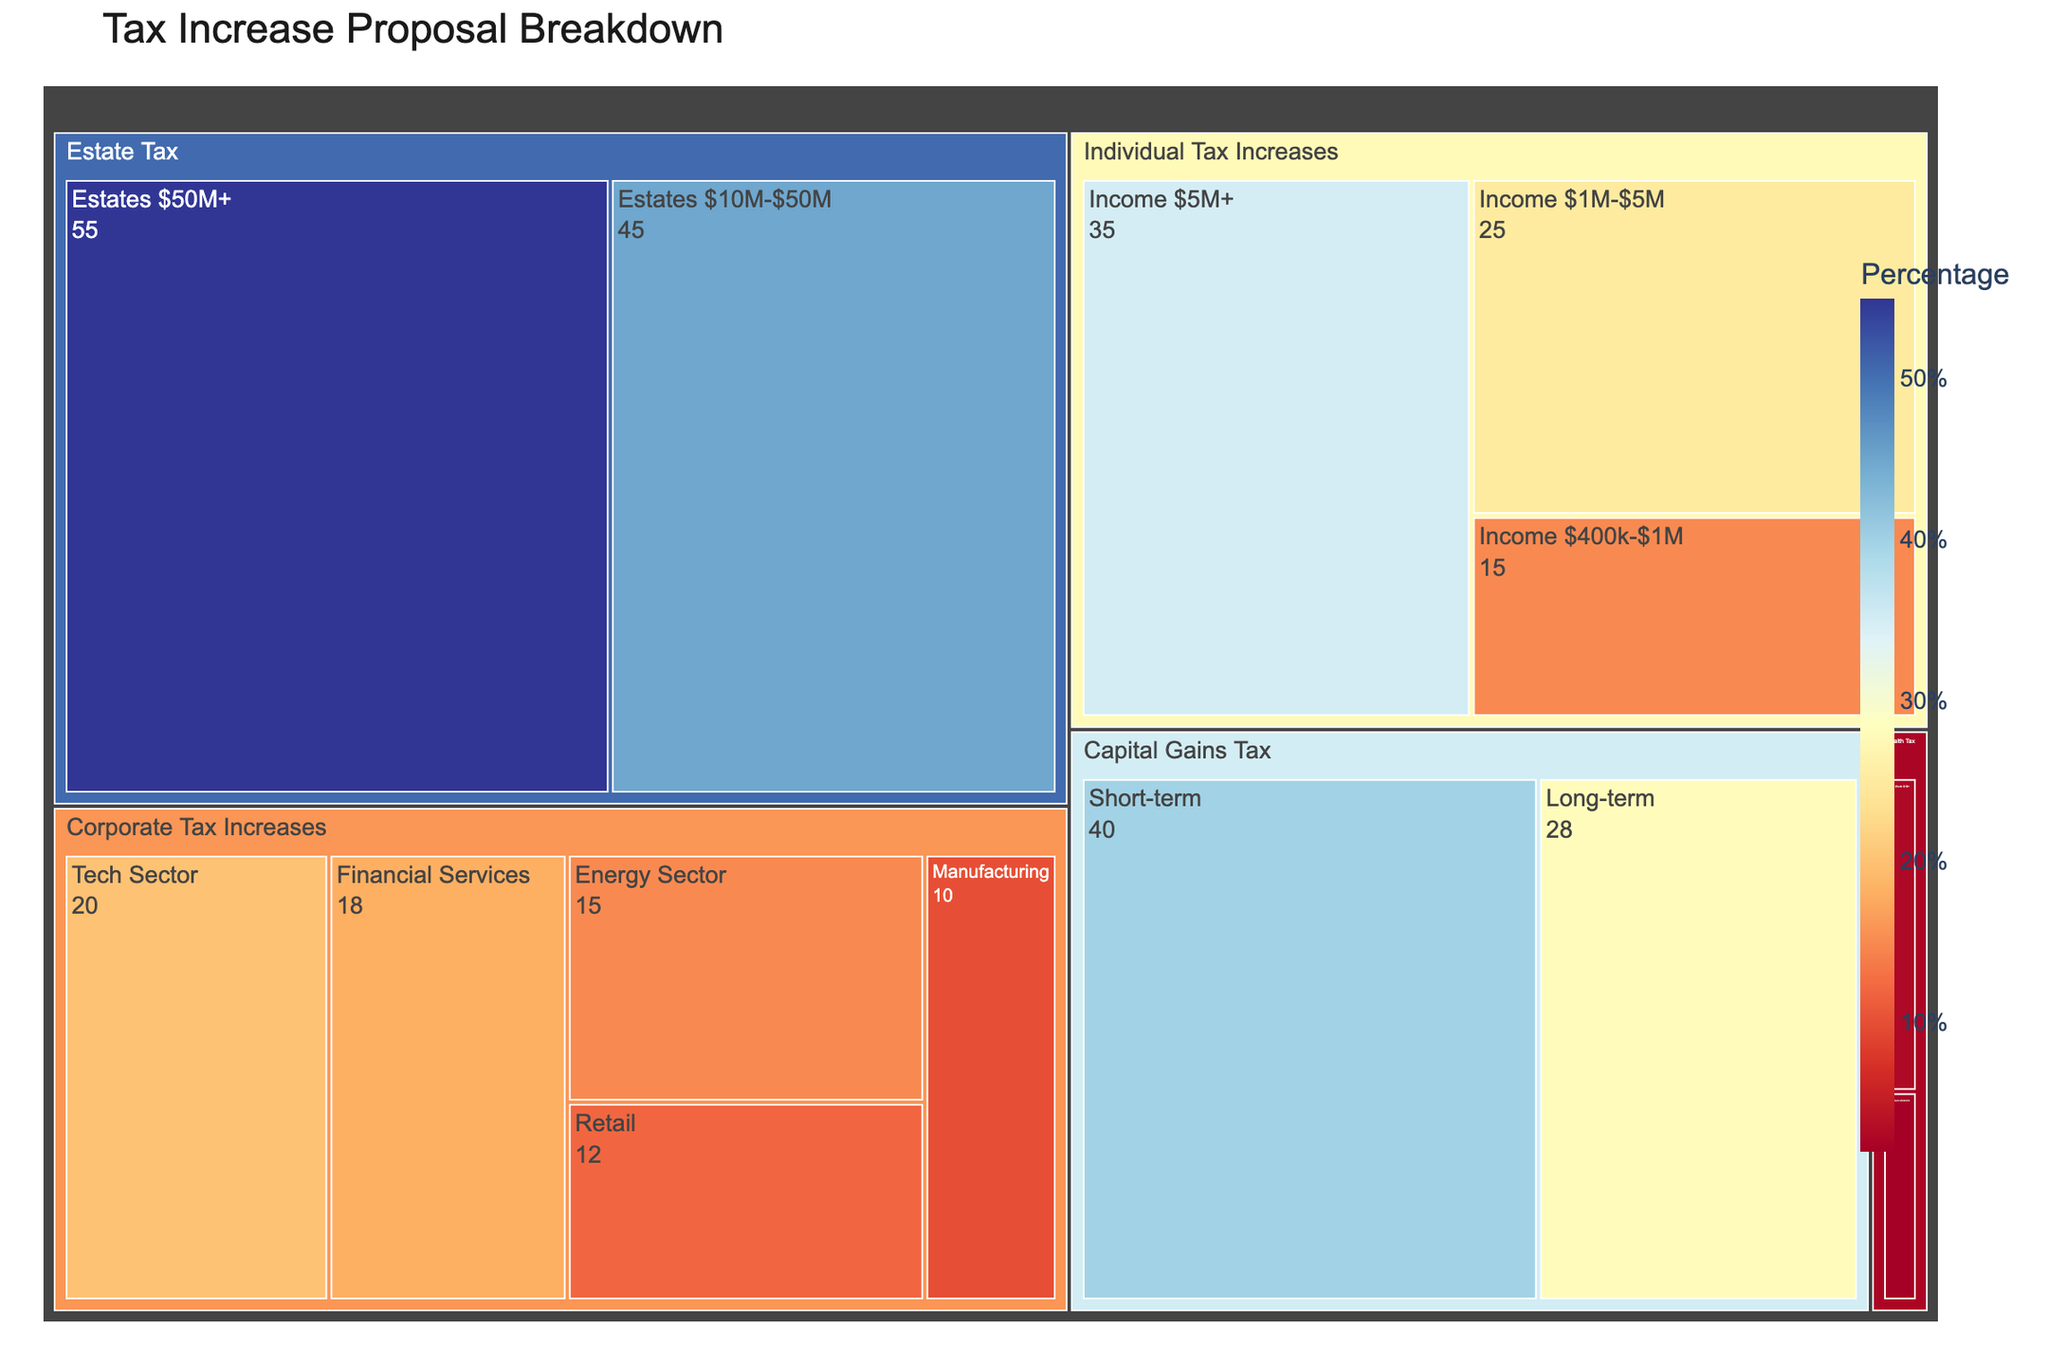What is the title of the Treemap? The title is displayed prominently at the top of the Treemap, typically in larger and bold font for visibility. In this case, the title is specified in the plotting code as well.
Answer: Tax Increase Proposal Breakdown Which subcategory has the highest percentage value for Estate Tax? By looking at the Estate Tax category and comparing the subcategories, the highest percentage value can be identified.
Answer: Estates $50M+ Which category has a greater total value: Individual Tax Increases or Capital Gains Tax? Add up the values in each subcategory for both Individual Tax Increases and Capital Gains Tax, then compare the sums. Individual Tax Increases has values of 15, 25, and 35, totaling 75. Capital Gains Tax has values of 40 and 28, totaling 68.
Answer: Individual Tax Increases What is the combined value of Corporate Tax Increases across all subcategories? Sum the values of all subcategories under Corporate Tax Increases: Tech Sector (20), Financial Services (18), Energy Sector (15), Retail (12), and Manufacturing (10). The combined value is 20 + 18 + 15 + 12 + 10.
Answer: 75 What is the percentage difference between the values for Long-term Capital Gains Tax and Short-term Capital Gains Tax? Subtract the value for Long-term Capital Gains Tax (28) from Short-term Capital Gains Tax (40) to find the difference. Then, divide by Short-term Capital Gains Tax, and multiply by 100 to convert to a percentage. (40 - 28) / 40 * 100 = 30%
Answer: 30% Which subcategory within Corporate Tax Increases has the smallest value? Compare the values of all subcategories within Corporate Tax Increases: Tech Sector (20), Financial Services (18), Energy Sector (15), Retail (12), and Manufacturing (10).
Answer: Manufacturing How does the value of Estates $10M-$50M compare to the Wealth Tax on Net Worth $50M-$1B? Compare the values of Estates $10M-$50M (45) and Wealth Tax on Net Worth $50M-$1B (2). Since 45 is much greater than 2, Estates $10M-$50M has the larger value.
Answer: Estates $10M-$50M has a much greater value What is the average value of all subcategories under Wealth Tax? Add the values of all subcategories under Wealth Tax: Net Worth $50M-$1B (2) and Net Worth $1B+ (3). Divide by the number of subcategories (2). (2 + 3) / 2 = 2.5
Answer: 2.5 What is the total value represented by all tax categories combined? Sum the values of all subcategories across all tax categories. (15 + 25 + 35 + 20 + 18 + 15 + 12 + 10 + 2 + 3 + 40 + 28 + 45 + 55). This yields a total of 323.
Answer: 323 